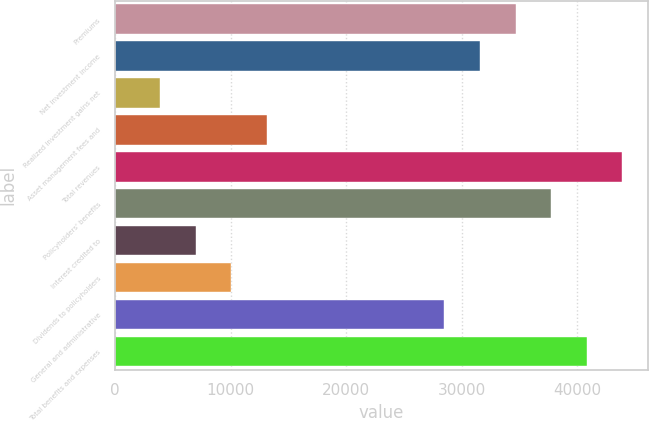Convert chart to OTSL. <chart><loc_0><loc_0><loc_500><loc_500><bar_chart><fcel>Premiums<fcel>Net investment income<fcel>Realized investment gains net<fcel>Asset management fees and<fcel>Total revenues<fcel>Policyholders' benefits<fcel>Interest credited to<fcel>Dividends to policyholders<fcel>General and administrative<fcel>Total benefits and expenses<nl><fcel>34678.1<fcel>31599<fcel>3887.1<fcel>13124.4<fcel>43915.4<fcel>37757.2<fcel>6966.2<fcel>10045.3<fcel>28519.9<fcel>40836.3<nl></chart> 